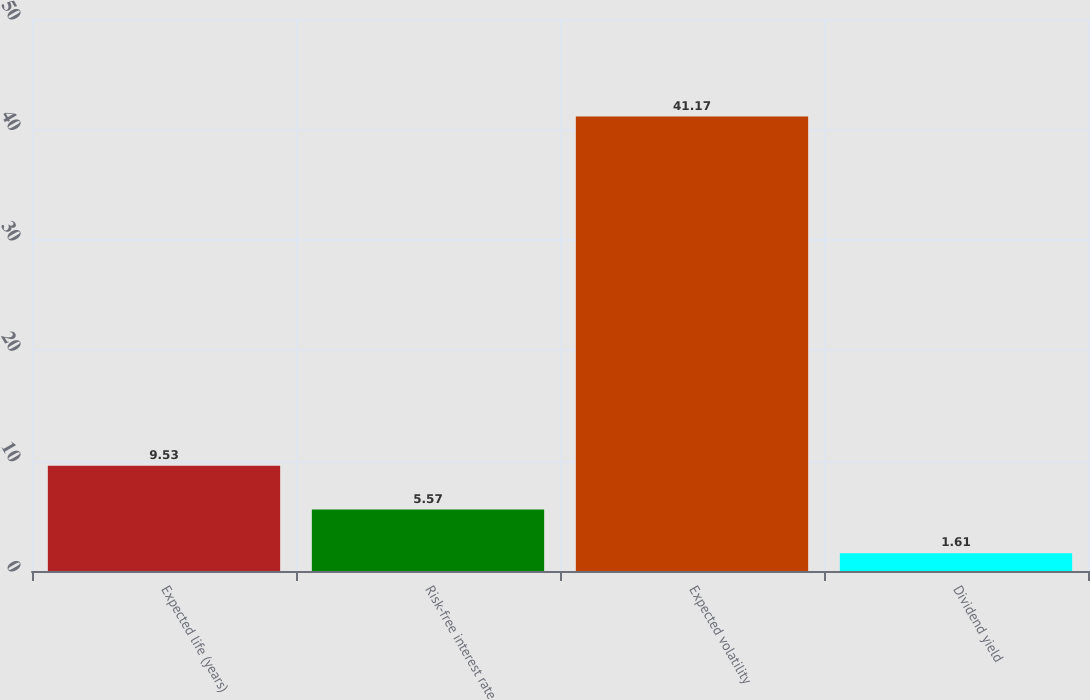Convert chart. <chart><loc_0><loc_0><loc_500><loc_500><bar_chart><fcel>Expected life (years)<fcel>Risk-free interest rate<fcel>Expected volatility<fcel>Dividend yield<nl><fcel>9.53<fcel>5.57<fcel>41.17<fcel>1.61<nl></chart> 